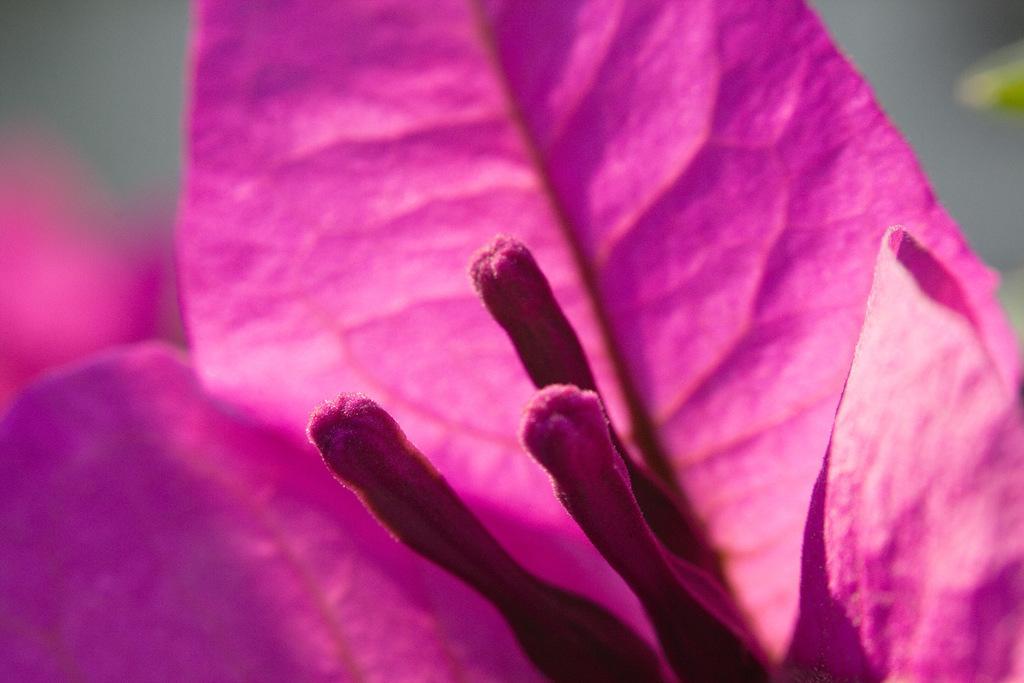Please provide a concise description of this image. This is the zoom-in picture of a pink flower. 